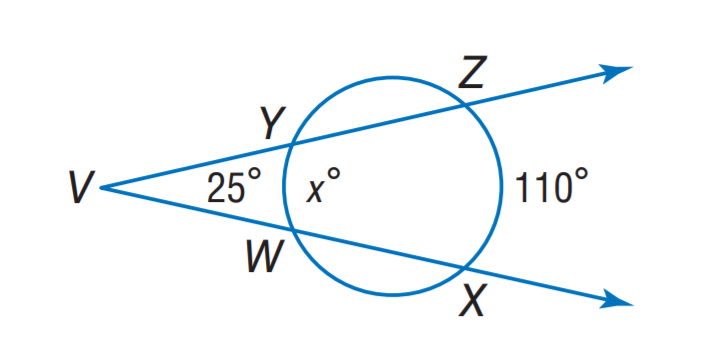Answer the mathemtical geometry problem and directly provide the correct option letter.
Question: Find x.
Choices: A: 50 B: 55 C: 60 D: 70 C 